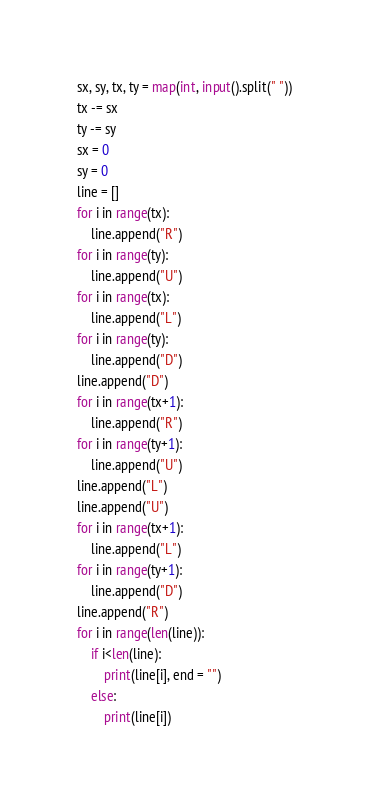<code> <loc_0><loc_0><loc_500><loc_500><_Python_>sx, sy, tx, ty = map(int, input().split(" "))
tx -= sx
ty -= sy
sx = 0
sy = 0
line = []
for i in range(tx):
    line.append("R")
for i in range(ty):
    line.append("U")
for i in range(tx):
    line.append("L")
for i in range(ty):
    line.append("D")
line.append("D")
for i in range(tx+1):
    line.append("R")
for i in range(ty+1):
    line.append("U")
line.append("L")
line.append("U")
for i in range(tx+1):
    line.append("L")
for i in range(ty+1):
    line.append("D")
line.append("R")
for i in range(len(line)):
    if i<len(line):
        print(line[i], end = "")
    else:
        print(line[i])</code> 